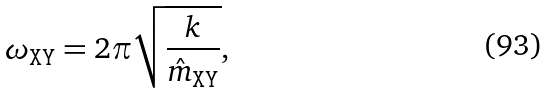<formula> <loc_0><loc_0><loc_500><loc_500>\omega _ { \tt X Y } = 2 \pi \sqrt { \frac { k } { \hat { m } _ { \tt X Y } } } ,</formula> 